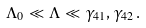Convert formula to latex. <formula><loc_0><loc_0><loc_500><loc_500>\Lambda _ { 0 } \ll \Lambda \ll \gamma _ { 4 1 } , \gamma _ { 4 2 } \, .</formula> 